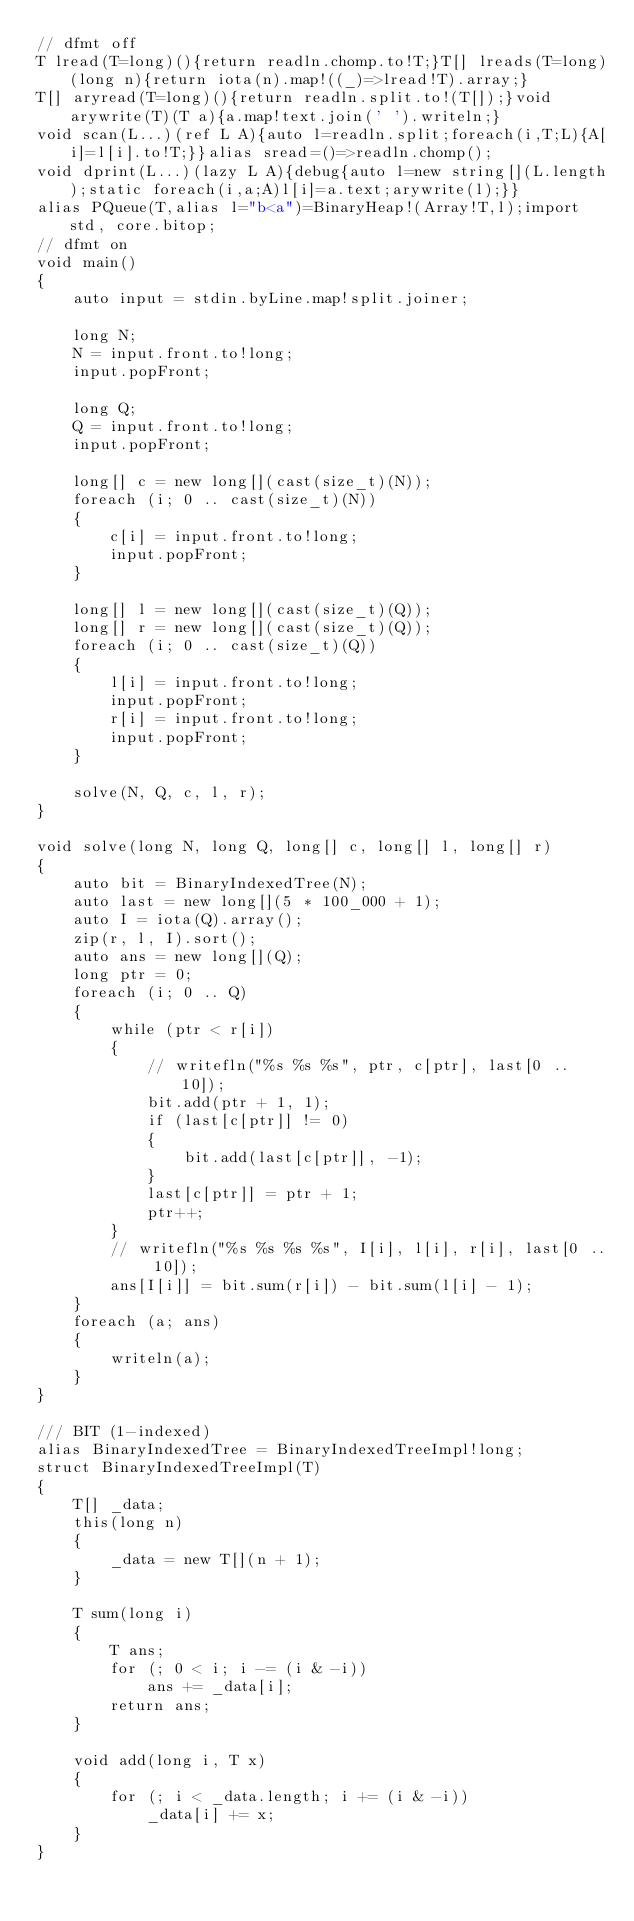<code> <loc_0><loc_0><loc_500><loc_500><_D_>// dfmt off
T lread(T=long)(){return readln.chomp.to!T;}T[] lreads(T=long)(long n){return iota(n).map!((_)=>lread!T).array;}
T[] aryread(T=long)(){return readln.split.to!(T[]);}void arywrite(T)(T a){a.map!text.join(' ').writeln;}
void scan(L...)(ref L A){auto l=readln.split;foreach(i,T;L){A[i]=l[i].to!T;}}alias sread=()=>readln.chomp();
void dprint(L...)(lazy L A){debug{auto l=new string[](L.length);static foreach(i,a;A)l[i]=a.text;arywrite(l);}}
alias PQueue(T,alias l="b<a")=BinaryHeap!(Array!T,l);import std, core.bitop;
// dfmt on
void main()
{
    auto input = stdin.byLine.map!split.joiner;

    long N;
    N = input.front.to!long;
    input.popFront;

    long Q;
    Q = input.front.to!long;
    input.popFront;

    long[] c = new long[](cast(size_t)(N));
    foreach (i; 0 .. cast(size_t)(N))
    {
        c[i] = input.front.to!long;
        input.popFront;
    }

    long[] l = new long[](cast(size_t)(Q));
    long[] r = new long[](cast(size_t)(Q));
    foreach (i; 0 .. cast(size_t)(Q))
    {
        l[i] = input.front.to!long;
        input.popFront;
        r[i] = input.front.to!long;
        input.popFront;
    }

    solve(N, Q, c, l, r);
}

void solve(long N, long Q, long[] c, long[] l, long[] r)
{
    auto bit = BinaryIndexedTree(N);
    auto last = new long[](5 * 100_000 + 1);
    auto I = iota(Q).array();
    zip(r, l, I).sort();
    auto ans = new long[](Q);
    long ptr = 0;
    foreach (i; 0 .. Q)
    {
        while (ptr < r[i])
        {
            // writefln("%s %s %s", ptr, c[ptr], last[0 .. 10]);
            bit.add(ptr + 1, 1);
            if (last[c[ptr]] != 0)
            {
                bit.add(last[c[ptr]], -1);
            }
            last[c[ptr]] = ptr + 1;
            ptr++;
        }
        // writefln("%s %s %s %s", I[i], l[i], r[i], last[0 .. 10]);
        ans[I[i]] = bit.sum(r[i]) - bit.sum(l[i] - 1);
    }
    foreach (a; ans)
    {
        writeln(a);
    }
}

/// BIT (1-indexed)
alias BinaryIndexedTree = BinaryIndexedTreeImpl!long;
struct BinaryIndexedTreeImpl(T)
{
    T[] _data;
    this(long n)
    {
        _data = new T[](n + 1);
    }

    T sum(long i)
    {
        T ans;
        for (; 0 < i; i -= (i & -i))
            ans += _data[i];
        return ans;
    }

    void add(long i, T x)
    {
        for (; i < _data.length; i += (i & -i))
            _data[i] += x;
    }
}
</code> 